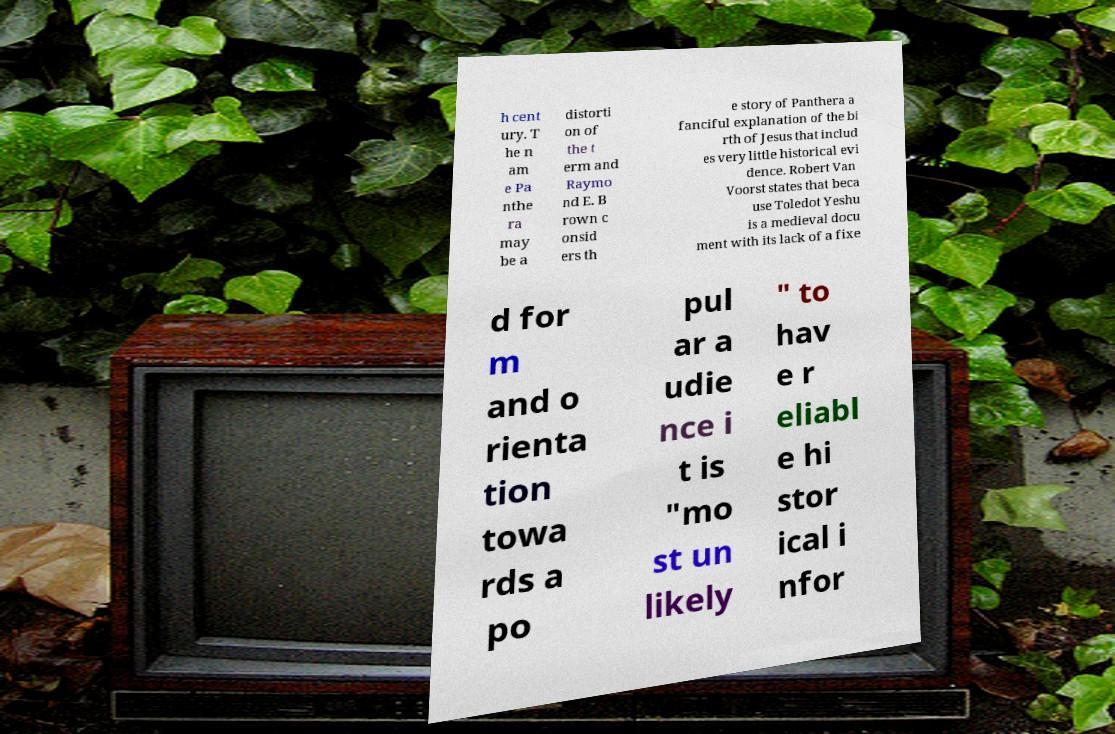There's text embedded in this image that I need extracted. Can you transcribe it verbatim? h cent ury. T he n am e Pa nthe ra may be a distorti on of the t erm and Raymo nd E. B rown c onsid ers th e story of Panthera a fanciful explanation of the bi rth of Jesus that includ es very little historical evi dence. Robert Van Voorst states that beca use Toledot Yeshu is a medieval docu ment with its lack of a fixe d for m and o rienta tion towa rds a po pul ar a udie nce i t is "mo st un likely " to hav e r eliabl e hi stor ical i nfor 